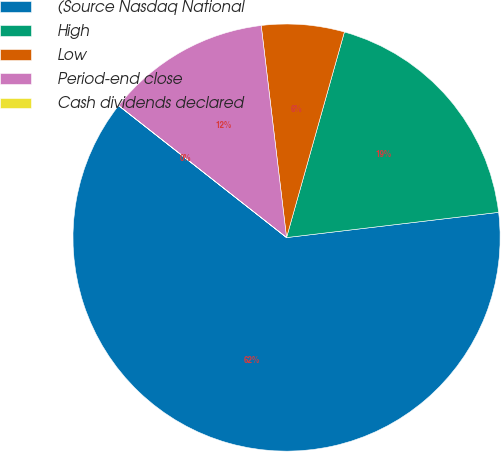<chart> <loc_0><loc_0><loc_500><loc_500><pie_chart><fcel>(Source Nasdaq National<fcel>High<fcel>Low<fcel>Period-end close<fcel>Cash dividends declared<nl><fcel>62.48%<fcel>18.75%<fcel>6.26%<fcel>12.5%<fcel>0.01%<nl></chart> 